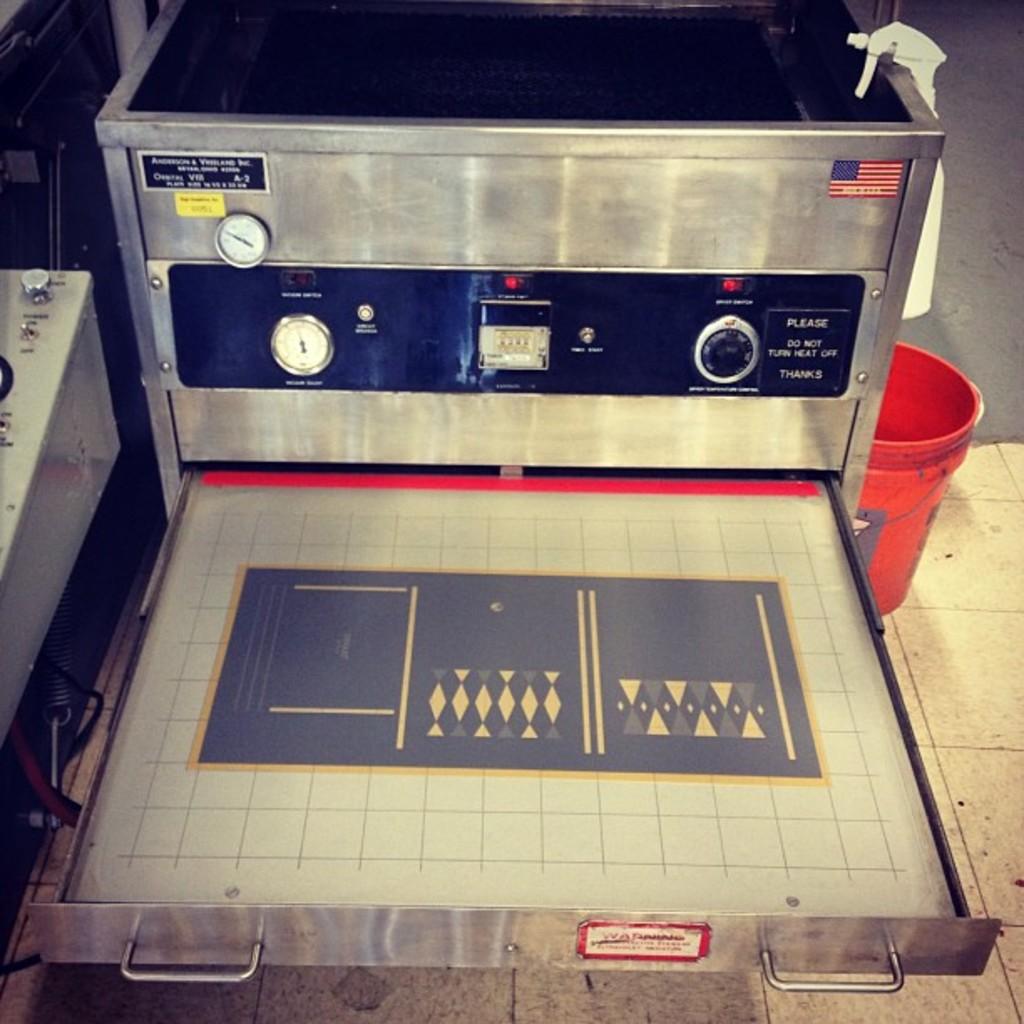Where was this device made?
Offer a very short reply. Usa. 